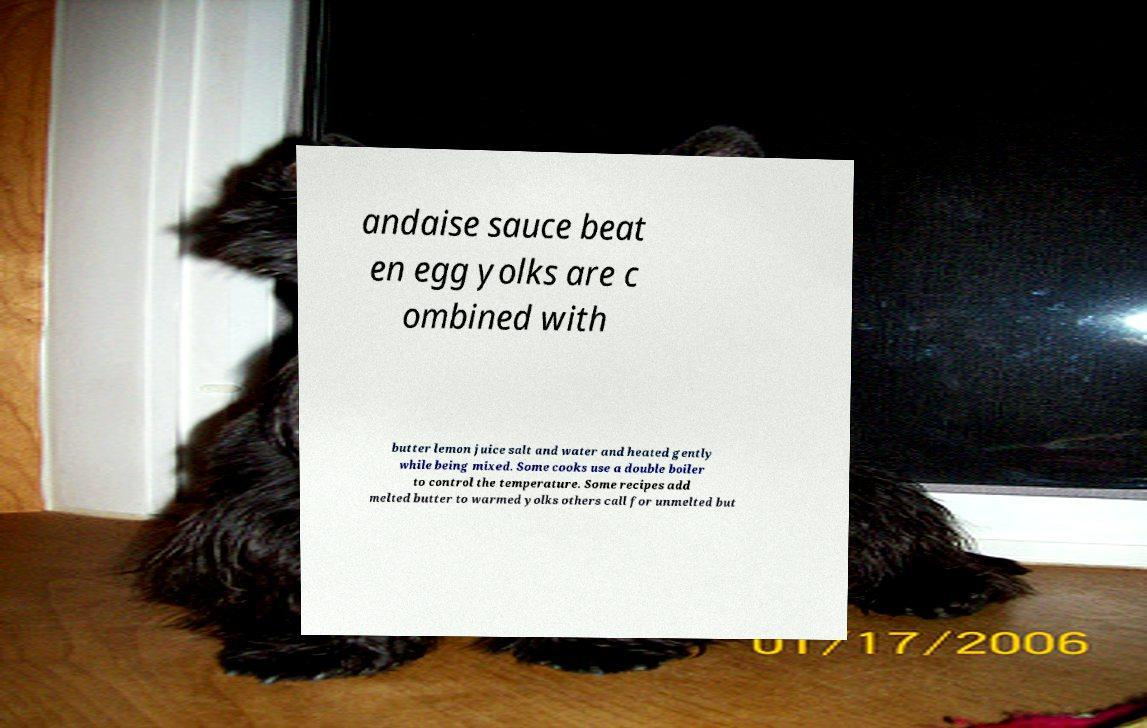I need the written content from this picture converted into text. Can you do that? andaise sauce beat en egg yolks are c ombined with butter lemon juice salt and water and heated gently while being mixed. Some cooks use a double boiler to control the temperature. Some recipes add melted butter to warmed yolks others call for unmelted but 